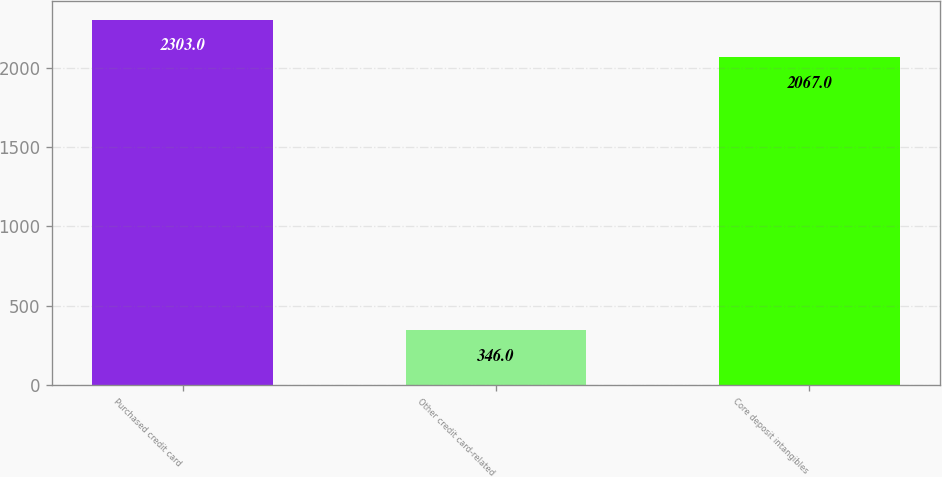Convert chart. <chart><loc_0><loc_0><loc_500><loc_500><bar_chart><fcel>Purchased credit card<fcel>Other credit card-related<fcel>Core deposit intangibles<nl><fcel>2303<fcel>346<fcel>2067<nl></chart> 